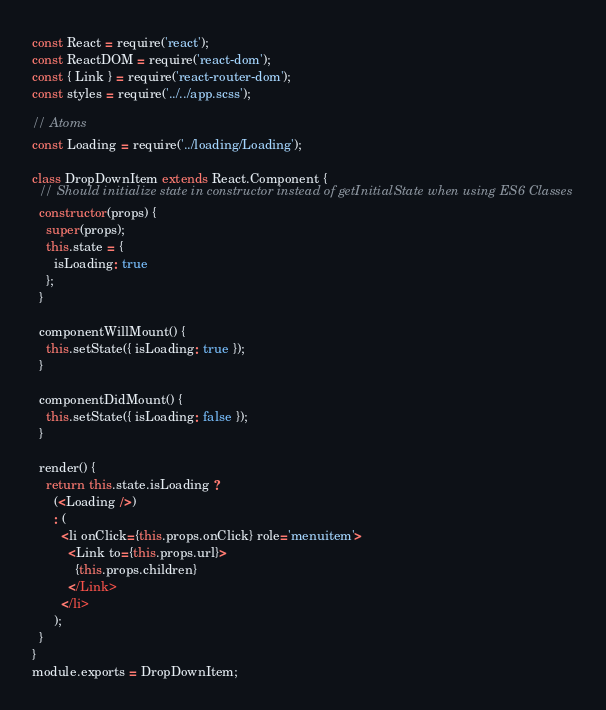<code> <loc_0><loc_0><loc_500><loc_500><_JavaScript_>const React = require('react');
const ReactDOM = require('react-dom');
const { Link } = require('react-router-dom');
const styles = require('../../app.scss');

// Atoms
const Loading = require('../loading/Loading');

class DropDownItem extends React.Component {
  // Should initialize state in constructor instead of getInitialState when using ES6 Classes
  constructor(props) {
    super(props);
    this.state = {
      isLoading: true
    };
  }

  componentWillMount() {
    this.setState({ isLoading: true });
  }

  componentDidMount() {
    this.setState({ isLoading: false });
  }

  render() {
    return this.state.isLoading ?
      (<Loading />)
      : (
        <li onClick={this.props.onClick} role='menuitem'>
          <Link to={this.props.url}>
            {this.props.children}
          </Link>
        </li>
      );
  }
}
module.exports = DropDownItem;</code> 